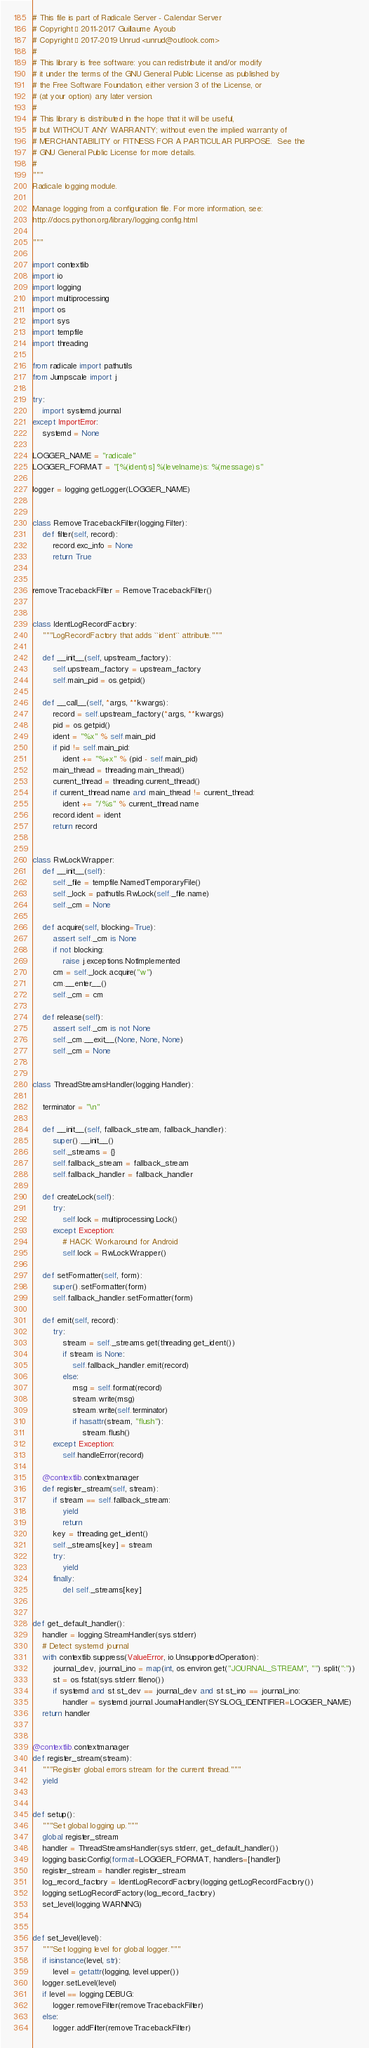<code> <loc_0><loc_0><loc_500><loc_500><_Python_># This file is part of Radicale Server - Calendar Server
# Copyright © 2011-2017 Guillaume Ayoub
# Copyright © 2017-2019 Unrud <unrud@outlook.com>
#
# This library is free software: you can redistribute it and/or modify
# it under the terms of the GNU General Public License as published by
# the Free Software Foundation, either version 3 of the License, or
# (at your option) any later version.
#
# This library is distributed in the hope that it will be useful,
# but WITHOUT ANY WARRANTY; without even the implied warranty of
# MERCHANTABILITY or FITNESS FOR A PARTICULAR PURPOSE.  See the
# GNU General Public License for more details.
#
"""
Radicale logging module.

Manage logging from a configuration file. For more information, see:
http://docs.python.org/library/logging.config.html

"""

import contextlib
import io
import logging
import multiprocessing
import os
import sys
import tempfile
import threading

from radicale import pathutils
from Jumpscale import j

try:
    import systemd.journal
except ImportError:
    systemd = None

LOGGER_NAME = "radicale"
LOGGER_FORMAT = "[%(ident)s] %(levelname)s: %(message)s"

logger = logging.getLogger(LOGGER_NAME)


class RemoveTracebackFilter(logging.Filter):
    def filter(self, record):
        record.exc_info = None
        return True


removeTracebackFilter = RemoveTracebackFilter()


class IdentLogRecordFactory:
    """LogRecordFactory that adds ``ident`` attribute."""

    def __init__(self, upstream_factory):
        self.upstream_factory = upstream_factory
        self.main_pid = os.getpid()

    def __call__(self, *args, **kwargs):
        record = self.upstream_factory(*args, **kwargs)
        pid = os.getpid()
        ident = "%x" % self.main_pid
        if pid != self.main_pid:
            ident += "%+x" % (pid - self.main_pid)
        main_thread = threading.main_thread()
        current_thread = threading.current_thread()
        if current_thread.name and main_thread != current_thread:
            ident += "/%s" % current_thread.name
        record.ident = ident
        return record


class RwLockWrapper:
    def __init__(self):
        self._file = tempfile.NamedTemporaryFile()
        self._lock = pathutils.RwLock(self._file.name)
        self._cm = None

    def acquire(self, blocking=True):
        assert self._cm is None
        if not blocking:
            raise j.exceptions.NotImplemented
        cm = self._lock.acquire("w")
        cm.__enter__()
        self._cm = cm

    def release(self):
        assert self._cm is not None
        self._cm.__exit__(None, None, None)
        self._cm = None


class ThreadStreamsHandler(logging.Handler):

    terminator = "\n"

    def __init__(self, fallback_stream, fallback_handler):
        super().__init__()
        self._streams = {}
        self.fallback_stream = fallback_stream
        self.fallback_handler = fallback_handler

    def createLock(self):
        try:
            self.lock = multiprocessing.Lock()
        except Exception:
            # HACK: Workaround for Android
            self.lock = RwLockWrapper()

    def setFormatter(self, form):
        super().setFormatter(form)
        self.fallback_handler.setFormatter(form)

    def emit(self, record):
        try:
            stream = self._streams.get(threading.get_ident())
            if stream is None:
                self.fallback_handler.emit(record)
            else:
                msg = self.format(record)
                stream.write(msg)
                stream.write(self.terminator)
                if hasattr(stream, "flush"):
                    stream.flush()
        except Exception:
            self.handleError(record)

    @contextlib.contextmanager
    def register_stream(self, stream):
        if stream == self.fallback_stream:
            yield
            return
        key = threading.get_ident()
        self._streams[key] = stream
        try:
            yield
        finally:
            del self._streams[key]


def get_default_handler():
    handler = logging.StreamHandler(sys.stderr)
    # Detect systemd journal
    with contextlib.suppress(ValueError, io.UnsupportedOperation):
        journal_dev, journal_ino = map(int, os.environ.get("JOURNAL_STREAM", "").split(":"))
        st = os.fstat(sys.stderr.fileno())
        if systemd and st.st_dev == journal_dev and st.st_ino == journal_ino:
            handler = systemd.journal.JournalHandler(SYSLOG_IDENTIFIER=LOGGER_NAME)
    return handler


@contextlib.contextmanager
def register_stream(stream):
    """Register global errors stream for the current thread."""
    yield


def setup():
    """Set global logging up."""
    global register_stream
    handler = ThreadStreamsHandler(sys.stderr, get_default_handler())
    logging.basicConfig(format=LOGGER_FORMAT, handlers=[handler])
    register_stream = handler.register_stream
    log_record_factory = IdentLogRecordFactory(logging.getLogRecordFactory())
    logging.setLogRecordFactory(log_record_factory)
    set_level(logging.WARNING)


def set_level(level):
    """Set logging level for global logger."""
    if isinstance(level, str):
        level = getattr(logging, level.upper())
    logger.setLevel(level)
    if level == logging.DEBUG:
        logger.removeFilter(removeTracebackFilter)
    else:
        logger.addFilter(removeTracebackFilter)
</code> 